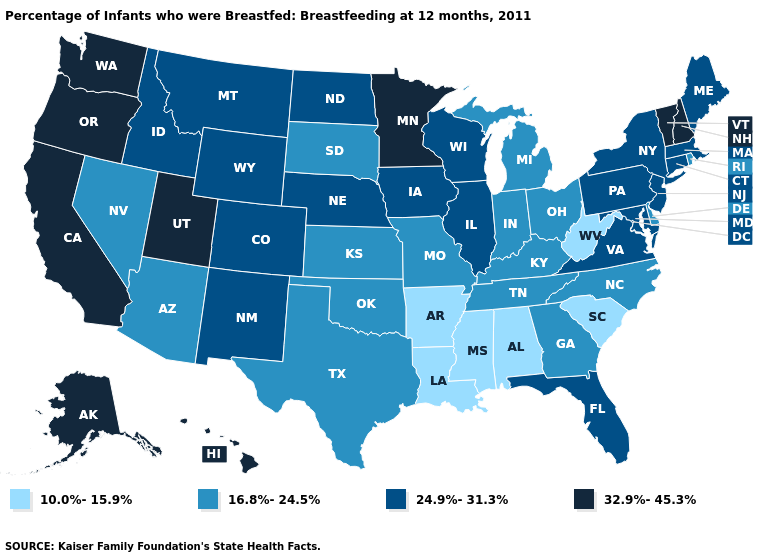Does the first symbol in the legend represent the smallest category?
Concise answer only. Yes. Name the states that have a value in the range 32.9%-45.3%?
Answer briefly. Alaska, California, Hawaii, Minnesota, New Hampshire, Oregon, Utah, Vermont, Washington. What is the lowest value in the West?
Give a very brief answer. 16.8%-24.5%. Does Virginia have a lower value than Rhode Island?
Quick response, please. No. Which states have the lowest value in the MidWest?
Keep it brief. Indiana, Kansas, Michigan, Missouri, Ohio, South Dakota. What is the highest value in the USA?
Short answer required. 32.9%-45.3%. Does the map have missing data?
Concise answer only. No. Which states have the highest value in the USA?
Concise answer only. Alaska, California, Hawaii, Minnesota, New Hampshire, Oregon, Utah, Vermont, Washington. Which states have the lowest value in the USA?
Answer briefly. Alabama, Arkansas, Louisiana, Mississippi, South Carolina, West Virginia. What is the value of Alabama?
Keep it brief. 10.0%-15.9%. Does the map have missing data?
Be succinct. No. What is the lowest value in states that border Georgia?
Give a very brief answer. 10.0%-15.9%. Name the states that have a value in the range 24.9%-31.3%?
Concise answer only. Colorado, Connecticut, Florida, Idaho, Illinois, Iowa, Maine, Maryland, Massachusetts, Montana, Nebraska, New Jersey, New Mexico, New York, North Dakota, Pennsylvania, Virginia, Wisconsin, Wyoming. Which states hav the highest value in the West?
Write a very short answer. Alaska, California, Hawaii, Oregon, Utah, Washington. Name the states that have a value in the range 16.8%-24.5%?
Be succinct. Arizona, Delaware, Georgia, Indiana, Kansas, Kentucky, Michigan, Missouri, Nevada, North Carolina, Ohio, Oklahoma, Rhode Island, South Dakota, Tennessee, Texas. 